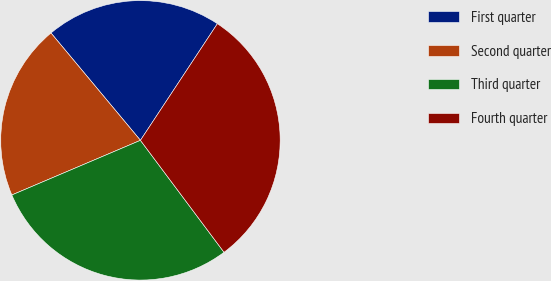Convert chart to OTSL. <chart><loc_0><loc_0><loc_500><loc_500><pie_chart><fcel>First quarter<fcel>Second quarter<fcel>Third quarter<fcel>Fourth quarter<nl><fcel>20.34%<fcel>20.34%<fcel>28.81%<fcel>30.51%<nl></chart> 